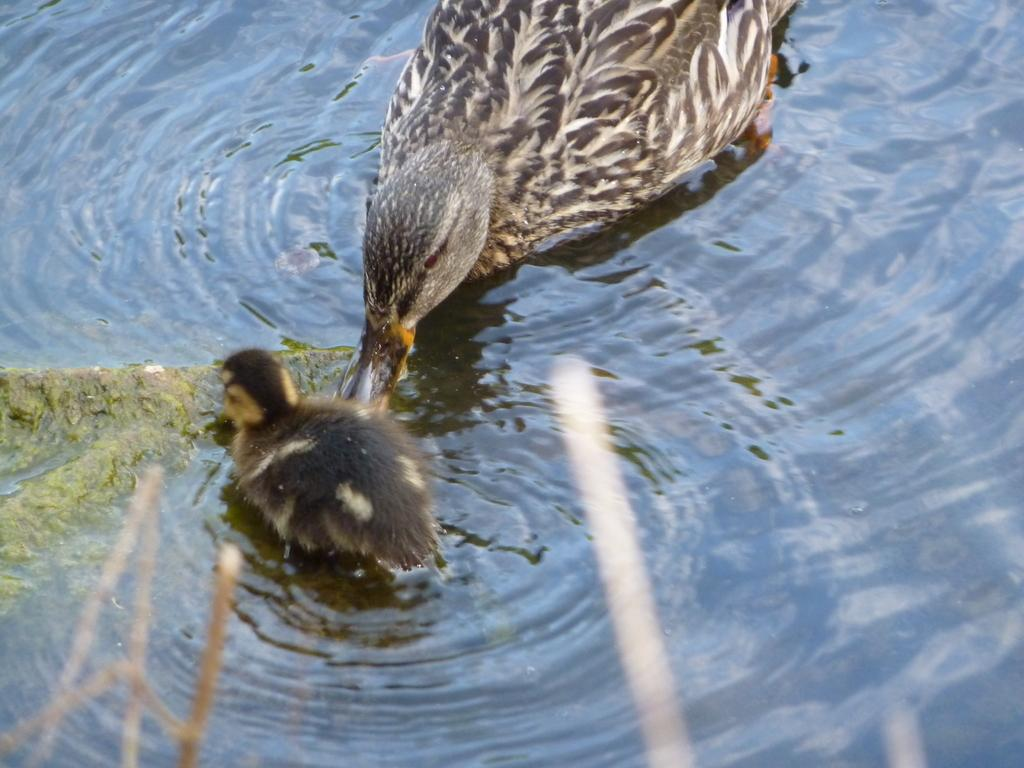What type of animals are in the image? There is a duck and a baby duck in the image. What are the duck and baby duck doing in the image? The duck and baby duck are drinking water. Where might the water be located in the image? The water might be in a pond. What is the lowest shelf in the image? There is no shelf present in the image, as it features a duck and baby duck drinking water, which is likely in a pond. 